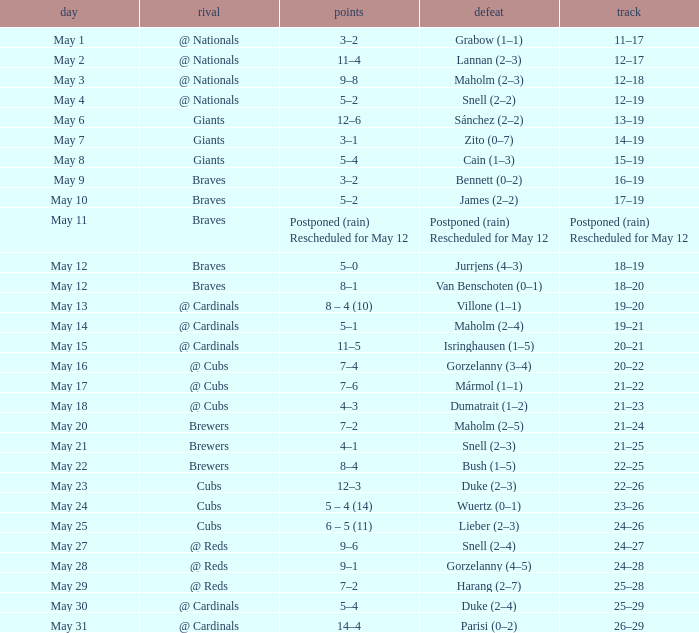What was the date of the game with a loss of Bush (1–5)? May 22. 